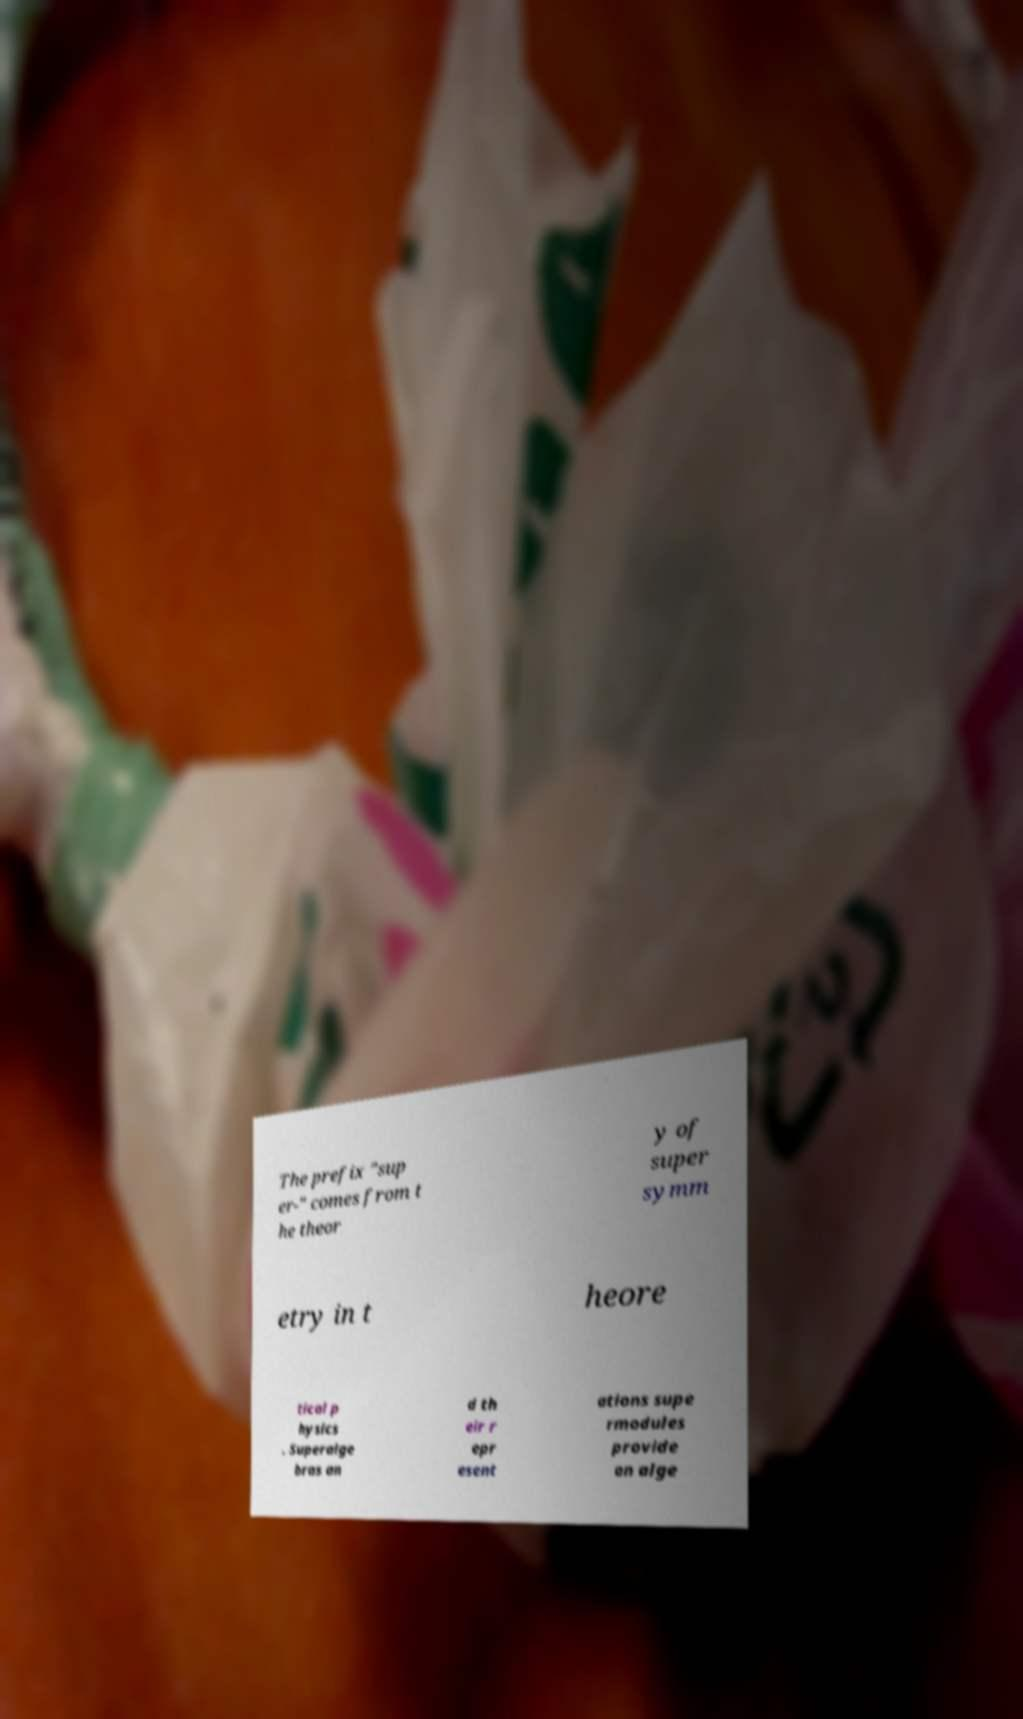Can you accurately transcribe the text from the provided image for me? The prefix "sup er-" comes from t he theor y of super symm etry in t heore tical p hysics . Superalge bras an d th eir r epr esent ations supe rmodules provide an alge 